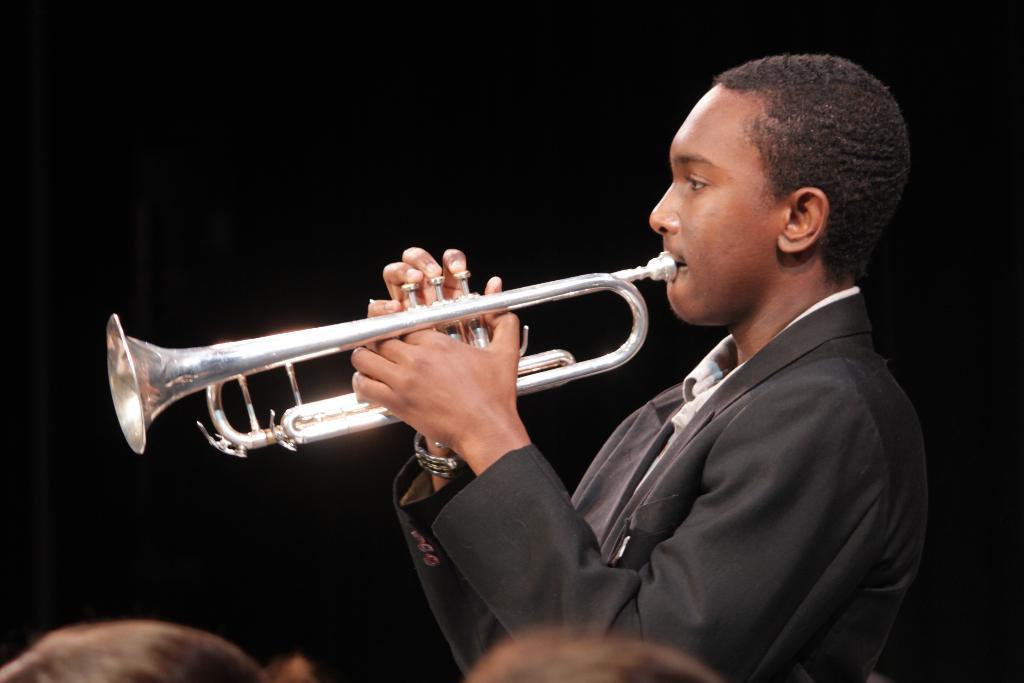How would you summarize this image in a sentence or two? In this picture we can see a person playing a trumpet, there is a dark background. 